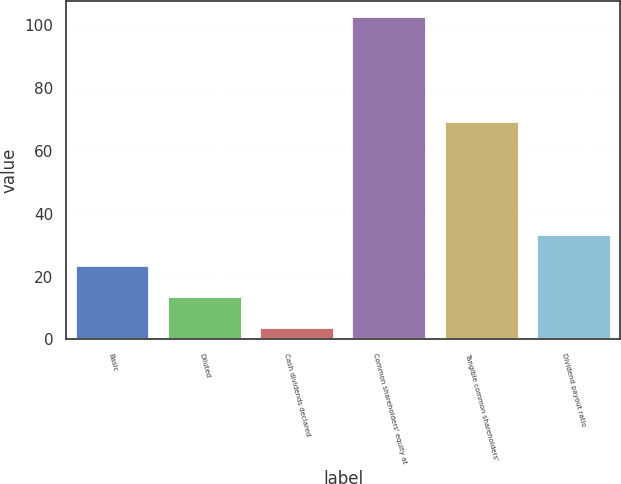<chart> <loc_0><loc_0><loc_500><loc_500><bar_chart><fcel>Basic<fcel>Diluted<fcel>Cash dividends declared<fcel>Common shareholders' equity at<fcel>Tangible common shareholders'<fcel>Dividend payout ratio<nl><fcel>23.37<fcel>13.46<fcel>3.55<fcel>102.69<fcel>69.28<fcel>33.28<nl></chart> 